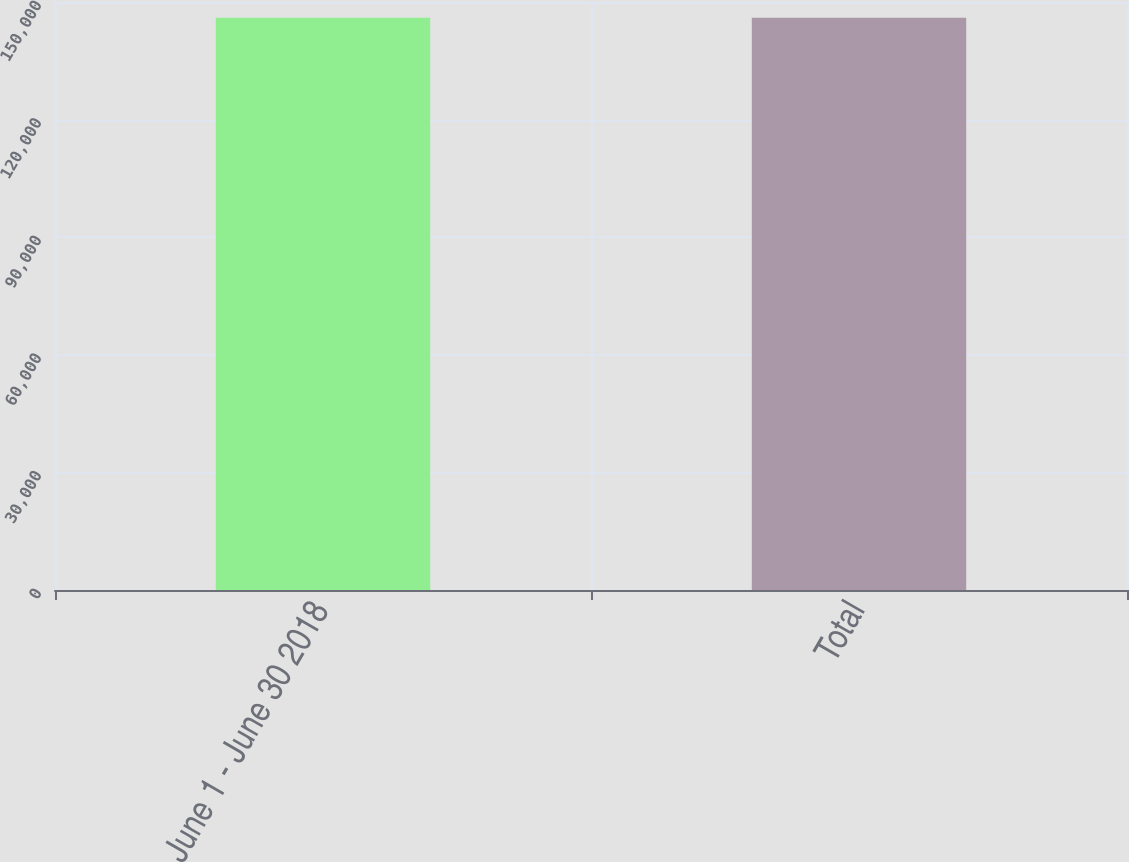<chart> <loc_0><loc_0><loc_500><loc_500><bar_chart><fcel>June 1 - June 30 2018<fcel>Total<nl><fcel>145983<fcel>145983<nl></chart> 